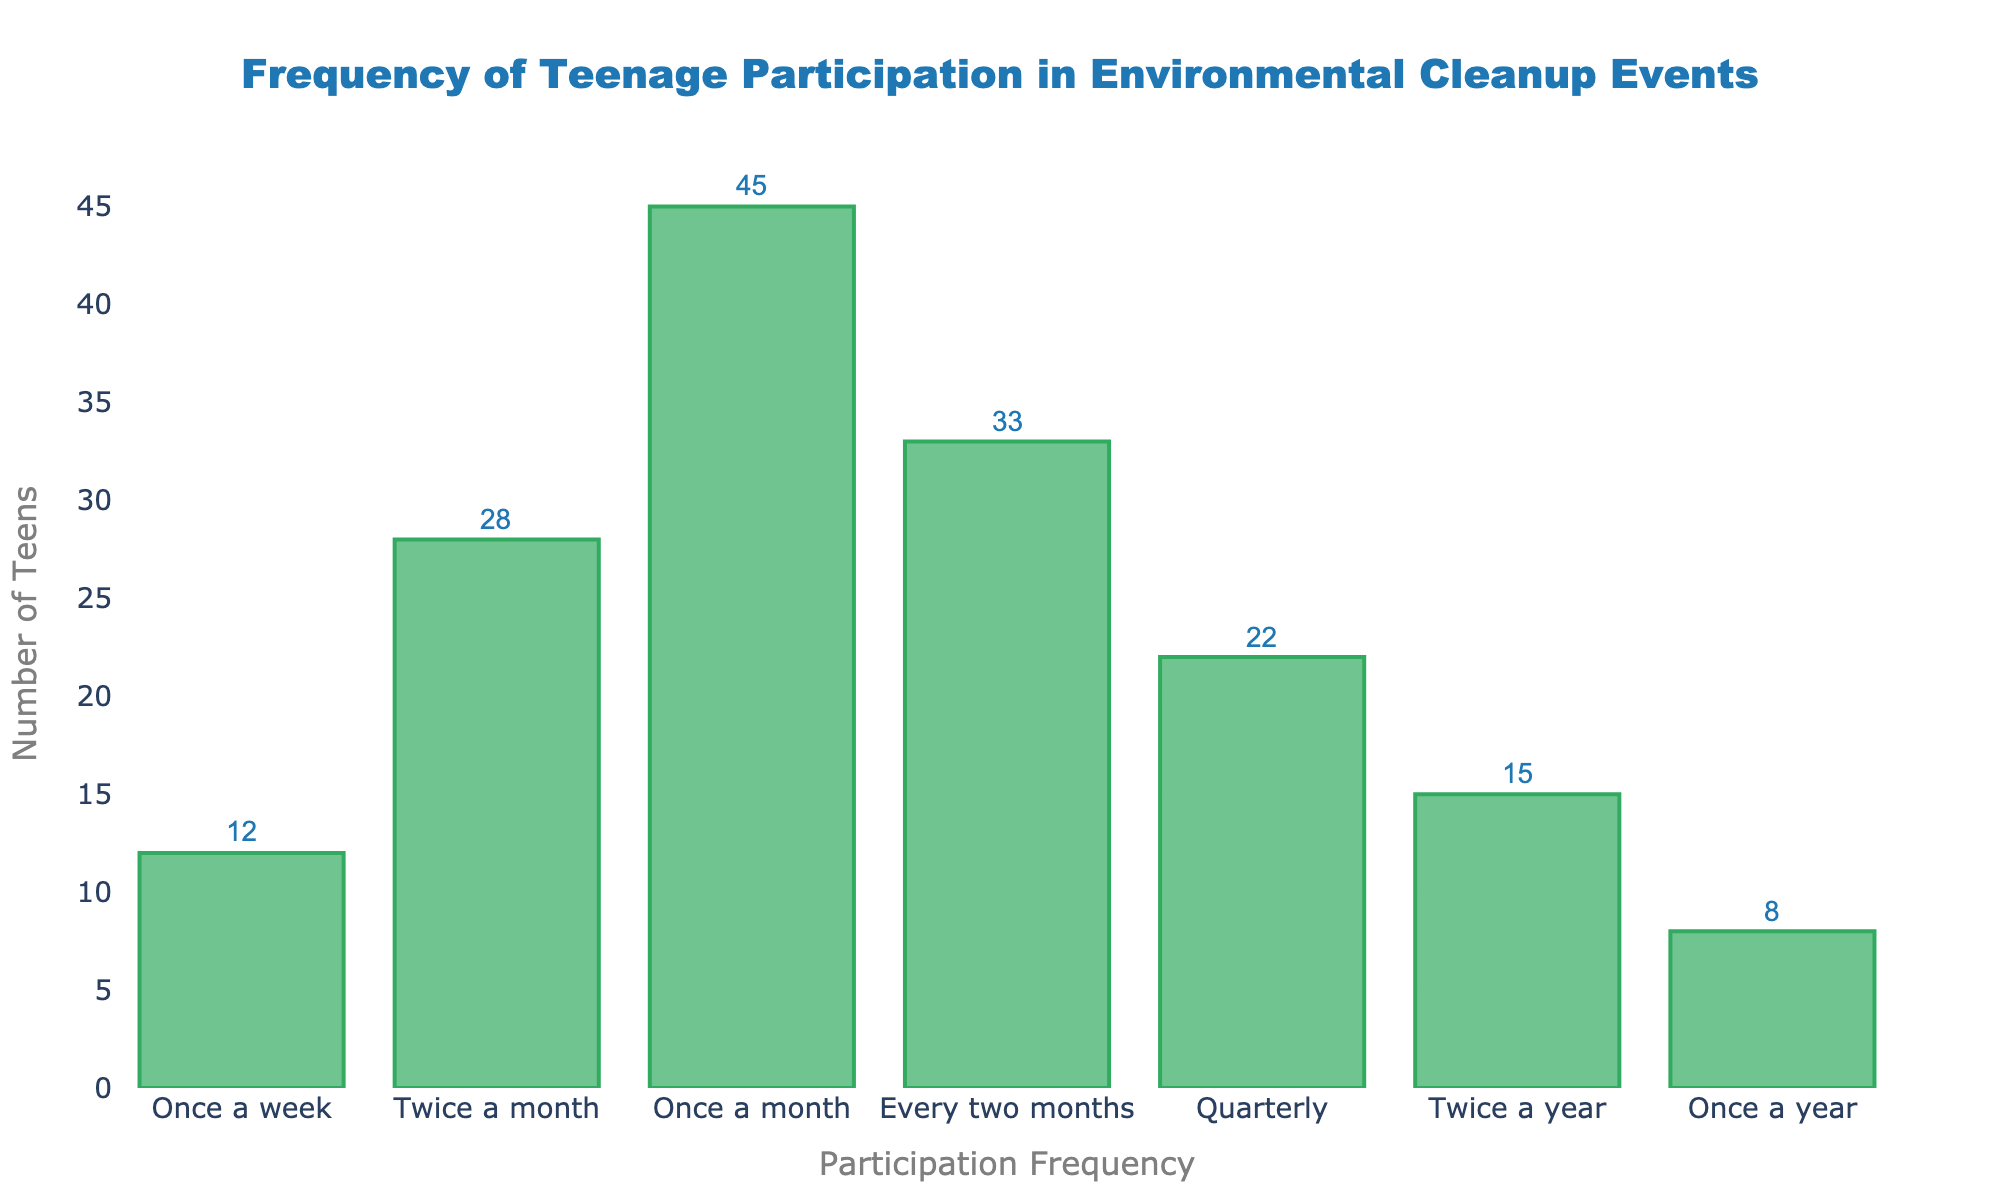What is the title of the figure? The title is usually found at the top of the figure. In this case, it reads "Frequency of Teenage Participation in Environmental Cleanup Events".
Answer: Frequency of Teenage Participation in Environmental Cleanup Events How many categories of participation frequency are shown in the histogram? The number of categories can be counted from the x-axis labels. The labels are "Once a week," "Twice a month," "Once a month," "Every two months," "Quarterly," "Twice a year," and "Once a year," giving us a total of seven categories.
Answer: 7 Which participation frequency category has the highest number of teens? By looking at the height of the bars and the annotations, the "Once a month" category has the highest bar with an annotation showing 45 teens.
Answer: Once a month What is the number of teens who participate in cleanups twice a year? The bar labeled "Twice a year" has an annotation indicating the number 15.
Answer: 15 How many teens participate in cleanups quarterly or more frequently? The categories that are quarterly or more frequent are "Once a week," "Twice a month," "Once a month," and "Quarterly." Summing their values (12 + 28 + 45 + 22) gives 107.
Answer: 107 Which participation frequency category has the lowest number of teens? The bar with the smallest height is "Once a year," which is annotated as 8 teens.
Answer: Once a year How does the number of teens participating once a week compare to those participating once a month? The bar for "Once a week" is 12, and the bar for "Once a month" is 45. Comparing them, 12 is less than 45.
Answer: Less What is the average number of teens participating in cleanups for all given frequencies? Add the numbers for all categories (12 + 28 + 45 + 33 + 22 + 15 + 8) to get a total of 163. Divide by the number of categories (7), which gives an average of approximately 23.3.
Answer: 23.3 What is the difference in the number of teens between those who participate quarterly and those who participate twice a month? The category for quarterly has 22 teens, and twice a month has 28. The difference is 28 - 22 = 6.
Answer: 6 What overall trend can be observed regarding the frequency of participation and the number of teens participating? By inspecting the histogram, there is a pattern where frequencies in the middle range (like once a month or every two months) have higher participation, while the extremes (like once a week and once a year) show lower participation.
Answer: Middle frequencies have higher participation, extremes have lower participation 